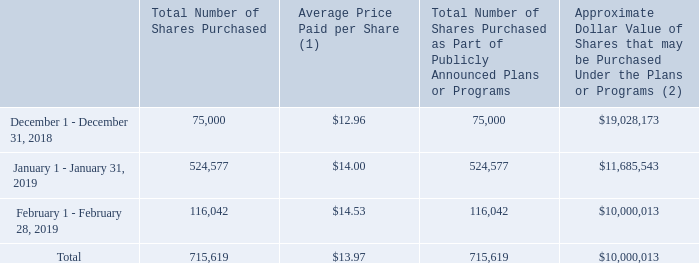Purchases of Equity Securities by the Issuer and Affiliated Purchasers
The following table contains information with respect to purchases made by or on behalf of CalAmp or any “affiliated purchaser” (as defined in Rule 10b-18(a)(3) under the Exchange Act), of our common stock during the following months of our fourth quarter ended February 28, 2019:
(1) Average price paid per share for shares purchased as part of our share repurchase program (includes brokerage commissions).
(2) On December 10, 2018, we announced that our Board of Directors authorized a new share repurchase program under which we may repurchase up to $20.0 million of our outstanding common stock over the next 12 months. As of February 28, 2019, $10.0 million of the $20.0 million had been utilized. Our share repurchase program does not obligate us to acquire any specific number of shares. Under the program, shares may be repurchased in privately negotiated and/or open market transactions, including under plans complying with Rule 10b5-1 under the Exchange Act.
How many shares were purchased in 2019? (524,577+116,042)
Answer: 640619. How many shares did the company purchase in December 2018? 75,000. What was the approximate dollar value of shares that may be purchased under the plans or program in December 2018? $19,028,173. What is the percentage increase in total number of shares purchased between December 2018 and January 2019?
Answer scale should be: percent. [(524,577-75,000)/75,000]
Answer: 599.44. What is the percentage change in Total number of shares purchased between January 2019 and February 2019?
Answer scale should be: percent. (116,042-524,577)/524,577
Answer: -77.88. How many shares did the company purchase in February 2019? 116,042. 